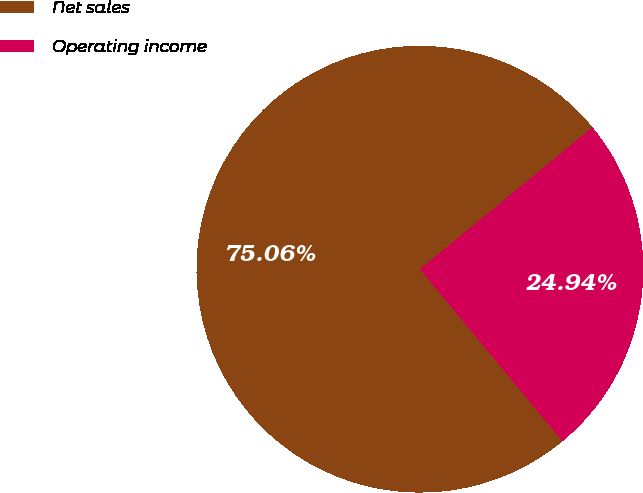<chart> <loc_0><loc_0><loc_500><loc_500><pie_chart><fcel>Net sales<fcel>Operating income<nl><fcel>75.06%<fcel>24.94%<nl></chart> 